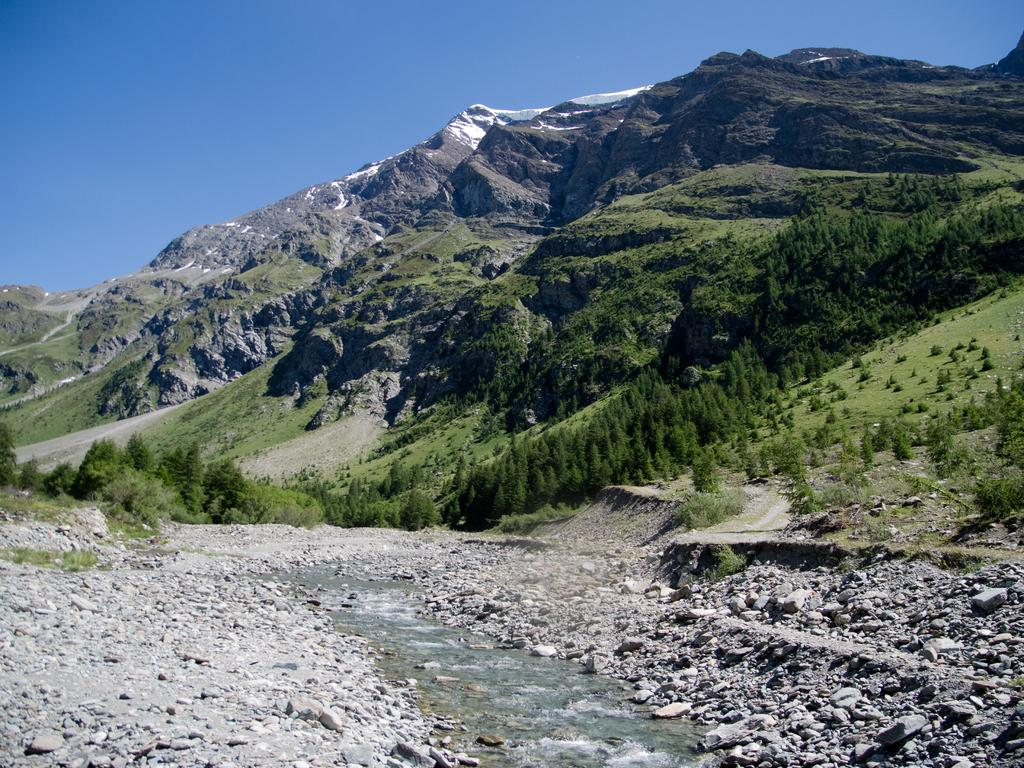What type of natural elements can be seen in the image? There are stones, water, trees, and mountains with snow visible in the image. Where is the water located in the image? The water is visible at the bottom of the image. What can be seen in the background of the image? There are trees and mountains with snow in the background of the image. What is visible at the top of the image? The sky is visible at the top of the image. Can you tell me how many baseballs are floating in the water in the image? There are no baseballs present in the image; it features stones, water, trees, and mountains with snow. What type of ice can be seen in the image? There is no ice visible in the image, only snow on the mountains in the background. 